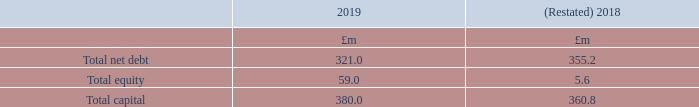Capital management
The Group considers capital to be net debt plus total equity. Net debt is calculated as total bank debt and lease financing, less unamortised debt fees and cash and cash equivalents as shown in note 32. Total equity is as shown in the Consolidated balance sheet.
The calculation of total capital is shown in the table below:
Following the application of IFRS 16, total capital for the year ended 31 March 2018 has been restated (note 2).
The objectives for managing capital are to safeguard the Group’s ability to continue as a going concern, in order to provide returns for shareholders and benefits for other stakeholders and to maintain an efficient capital structure to optimise the cost of capital. In order to maintain or adjust the capital structure, the Group may adjust the amount of dividends paid to shareholders, return capital to shareholders, issue new shares or take other steps to increase share capital and reduce or increase debt facilities.
As at 31 March 2019, the Group had borrowings of £313.0m (2018: £343.0m) through its Syndicated revolving credit facility (2018: Syndicated Term Loan). Interest is payable on this facility at a rate of LIBOR plus a margin of between 1.2% and 2.1% depending on the consolidated leverage ratio of Auto Trader Group plc and its subsidiaries, which is calculated and reviewed on a biannual basis. The Group remains in compliance with its banking covenants.
How is net debt calculated? Net debt is calculated as total bank debt and lease financing, less unamortised debt fees and cash and cash equivalents as shown in note 32. What was the amount of borrowings the Group had as at 31 March 2019? Borrowings of £313.0m (2018: £343.0m) through its syndicated revolving credit facility (2018: syndicated term loan). What are the components in the table used for the calculation of total capital? Total net debt, total equity. In which year was total capital larger? 380.0>360.8
Answer: 2019. What was the change in total capital in 2019 from 2018?
Answer scale should be: million. 380.0-360.8
Answer: 19.2. What was the percentage change in total capital in 2019 from 2018?
Answer scale should be: percent. (380.0-360.8)/360.8
Answer: 5.32. 